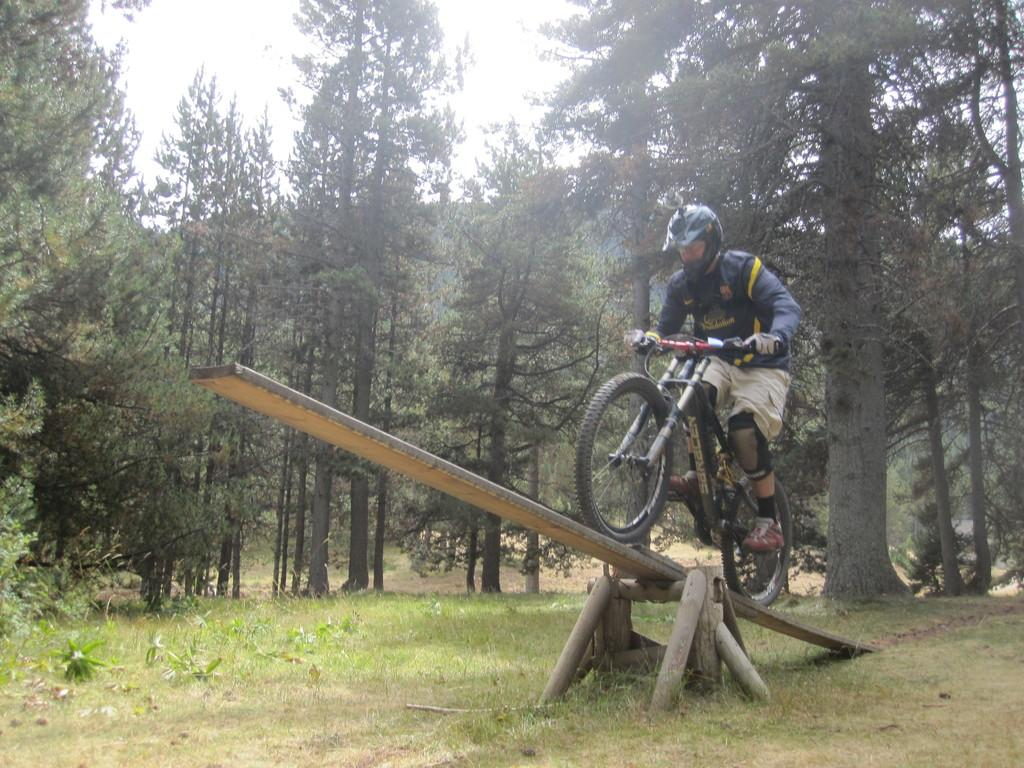What is the person in the image doing? The person is sitting on a bicycle. What is unique about the bicycle's position in the image? The bicycle is on a seesaw. What can be seen in the background of the image? There is ground, trees, and the sky visible in the background of the image. What type of prose can be heard being read aloud in the image? There is no indication in the image that prose is being read aloud, as the image primarily features a person on a bicycle on a seesaw. 